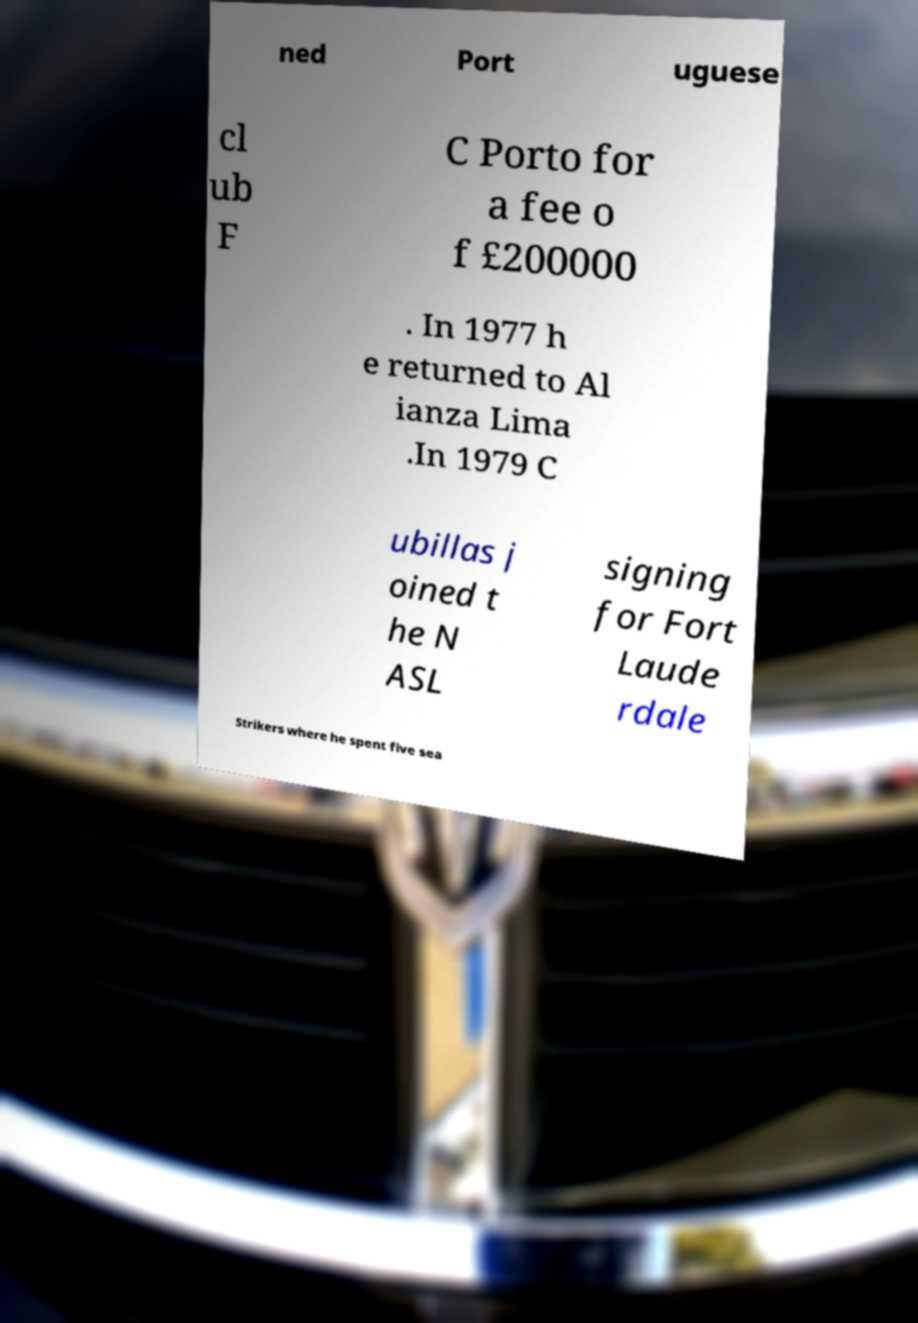Please read and relay the text visible in this image. What does it say? ned Port uguese cl ub F C Porto for a fee o f £200000 . In 1977 h e returned to Al ianza Lima .In 1979 C ubillas j oined t he N ASL signing for Fort Laude rdale Strikers where he spent five sea 